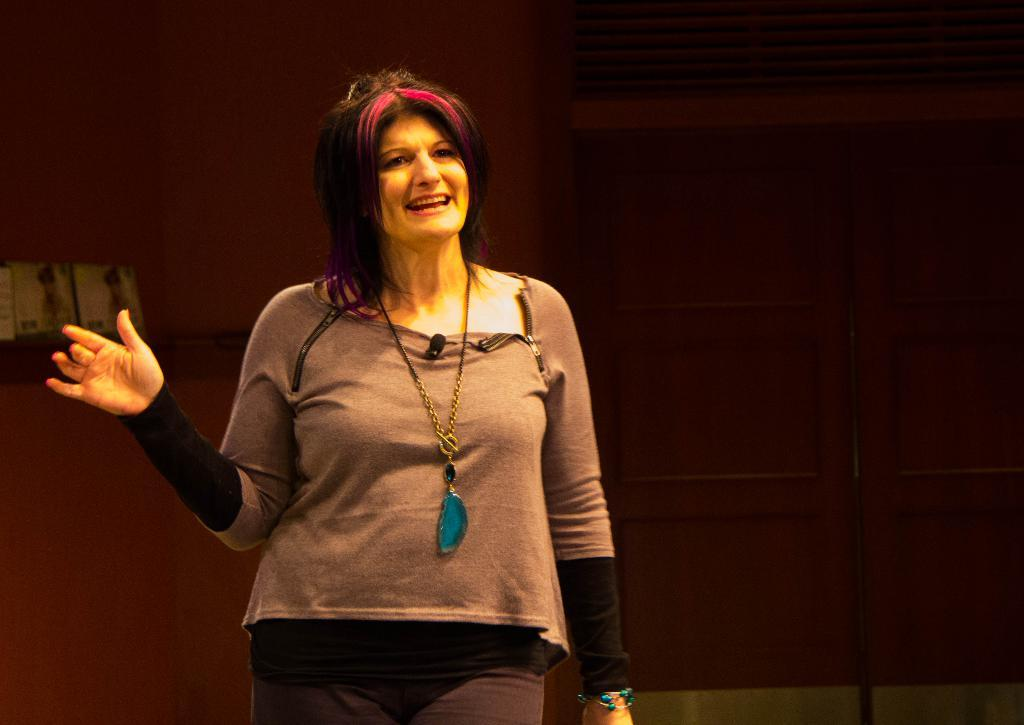What is the main subject of the image? There is a person standing in the image. Can you describe the person's attire? The person is wearing a brown and black color dress. What can be seen in the background of the image? The background of the image is brown in color. What type of meat is being served at the person's birthday party in the image? There is no indication of a birthday party or any meat in the image. 